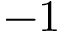Convert formula to latex. <formula><loc_0><loc_0><loc_500><loc_500>- 1</formula> 